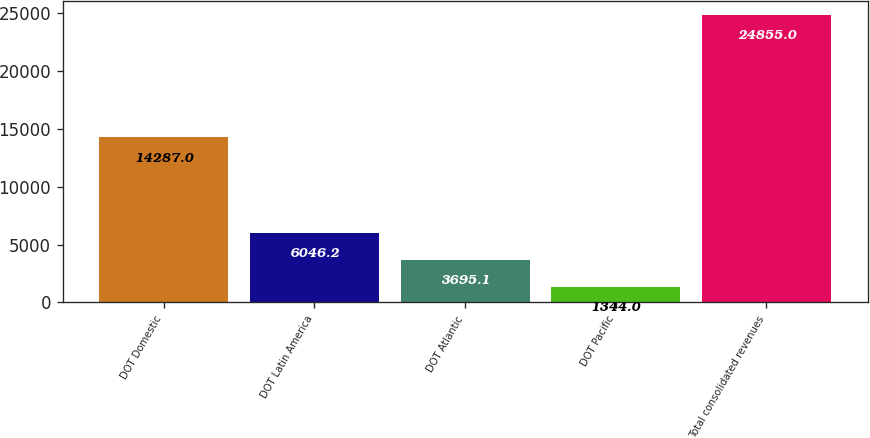Convert chart to OTSL. <chart><loc_0><loc_0><loc_500><loc_500><bar_chart><fcel>DOT Domestic<fcel>DOT Latin America<fcel>DOT Atlantic<fcel>DOT Pacific<fcel>Total consolidated revenues<nl><fcel>14287<fcel>6046.2<fcel>3695.1<fcel>1344<fcel>24855<nl></chart> 